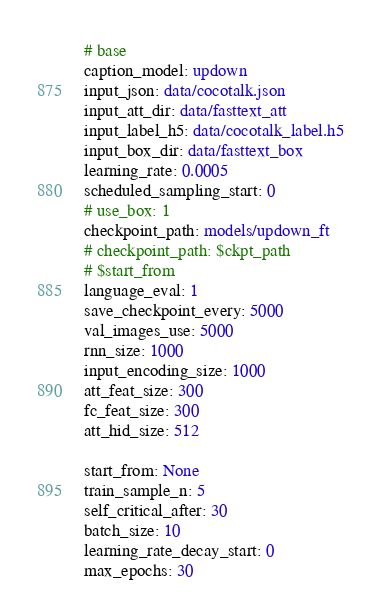Convert code to text. <code><loc_0><loc_0><loc_500><loc_500><_YAML_># base
caption_model: updown
input_json: data/cocotalk.json
input_att_dir: data/fasttext_att
input_label_h5: data/cocotalk_label.h5
input_box_dir: data/fasttext_box
learning_rate: 0.0005
scheduled_sampling_start: 0
# use_box: 1
checkpoint_path: models/updown_ft
# checkpoint_path: $ckpt_path
# $start_from
language_eval: 1
save_checkpoint_every: 5000
val_images_use: 5000
rnn_size: 1000
input_encoding_size: 1000
att_feat_size: 300
fc_feat_size: 300
att_hid_size: 512

start_from: None
train_sample_n: 5
self_critical_after: 30
batch_size: 10
learning_rate_decay_start: 0
max_epochs: 30
</code> 